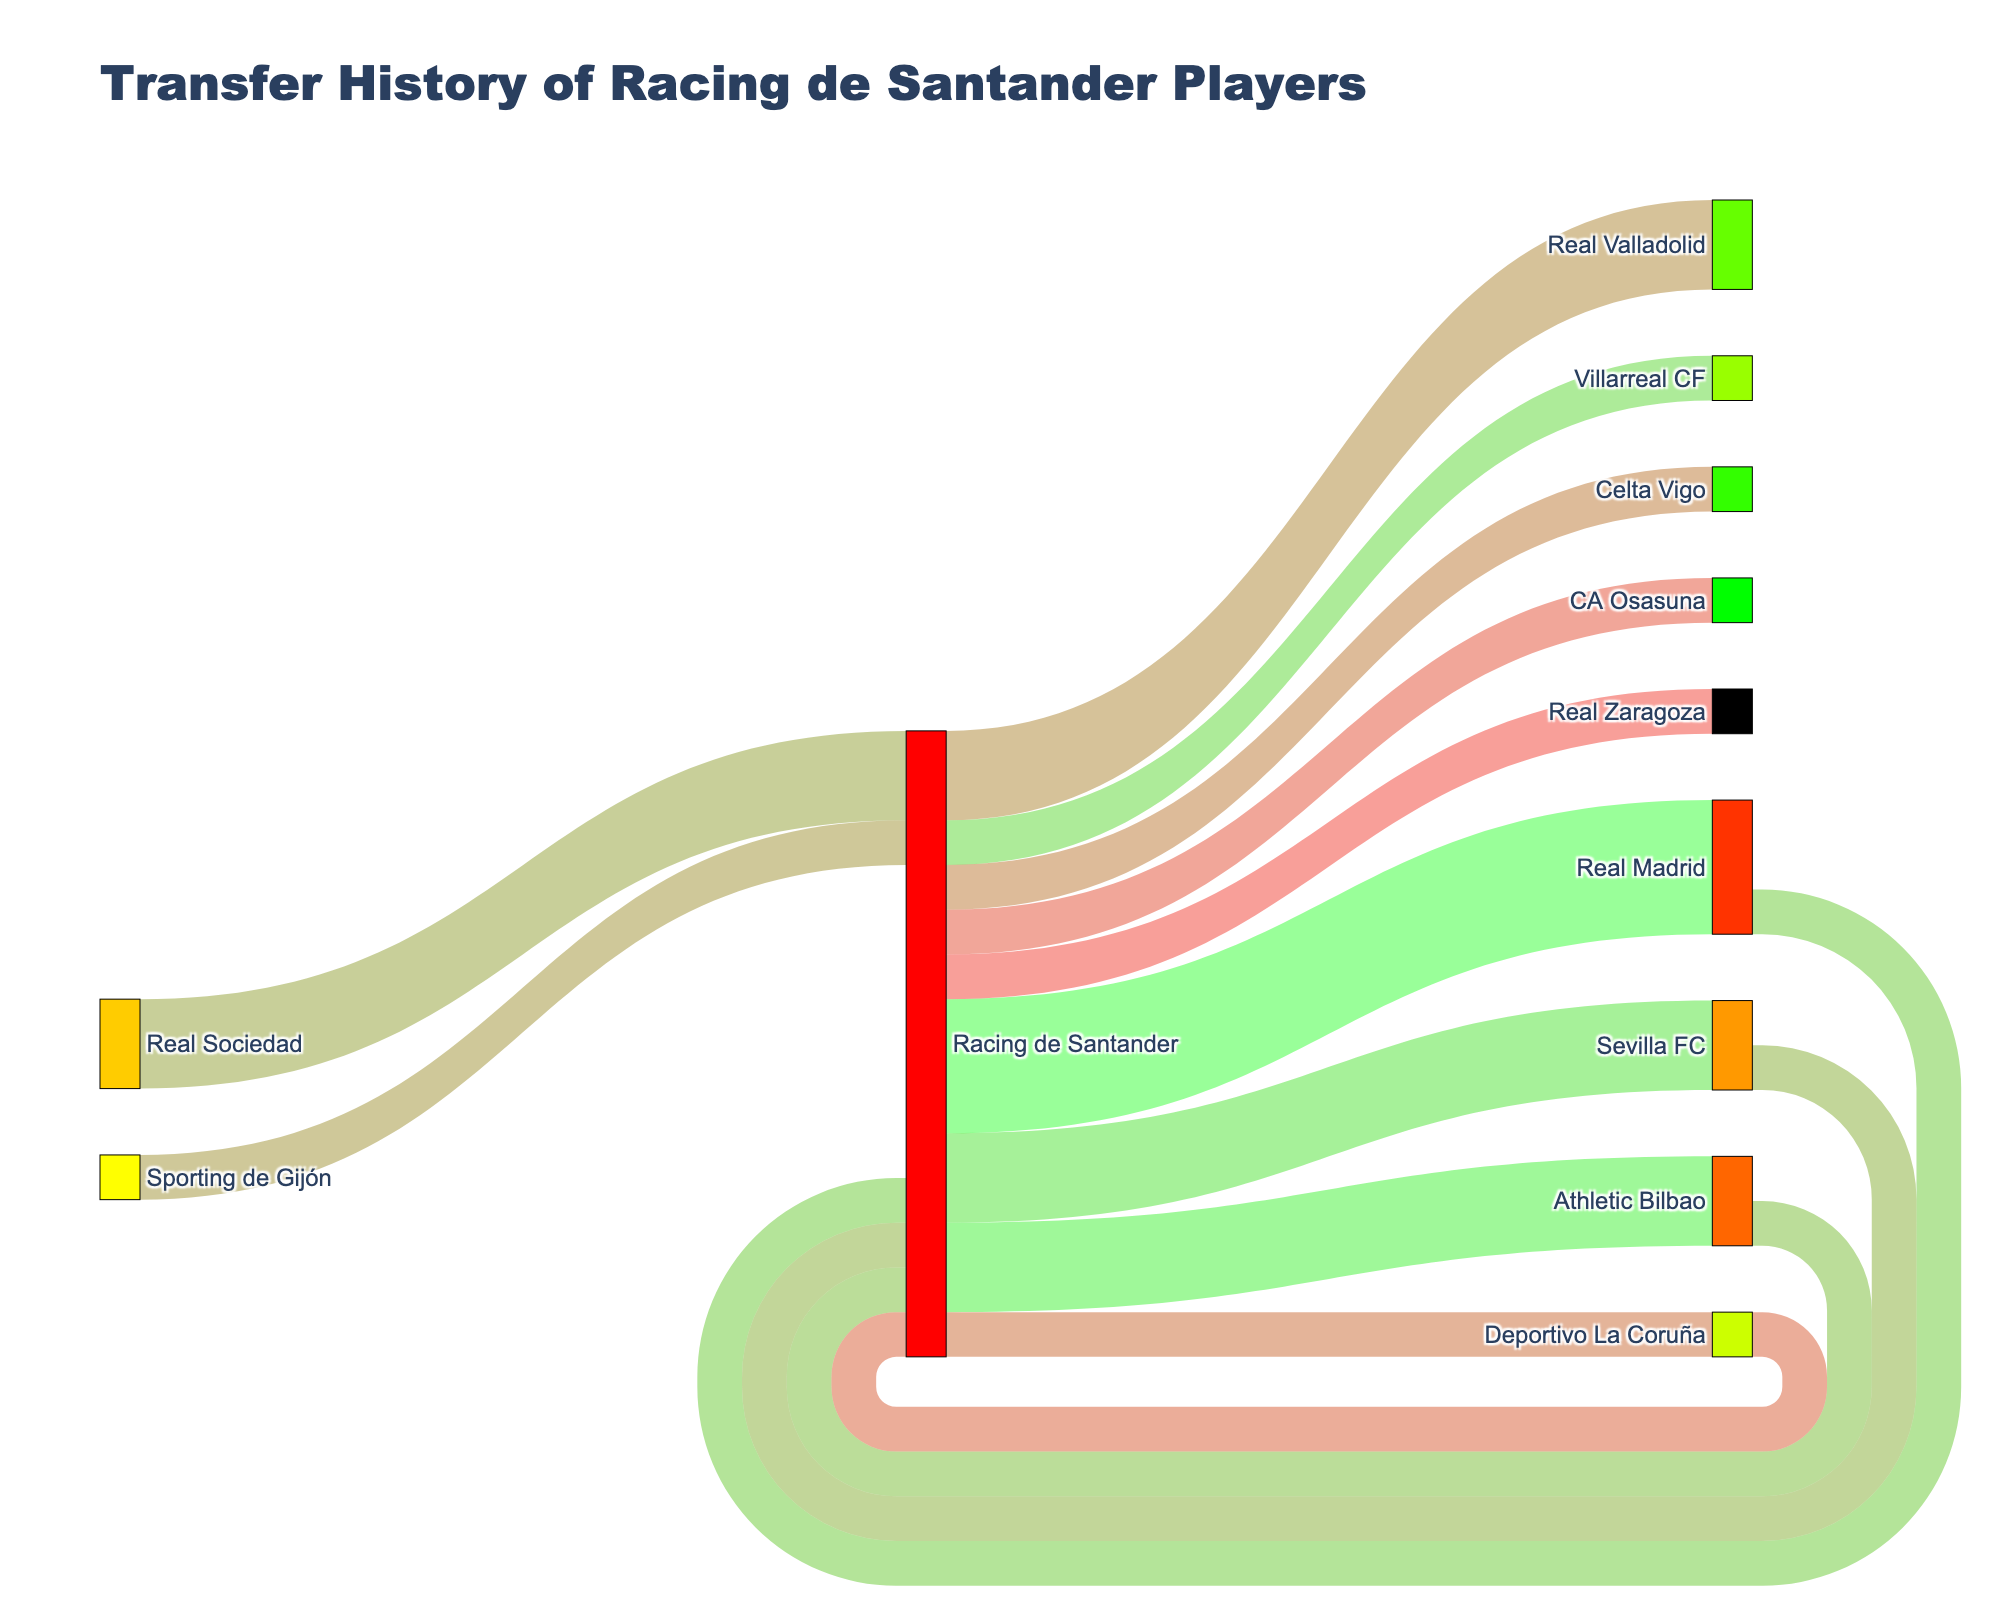How many clubs received players from Racing de Santander? Look at the number of unique target nodes connected to Racing de Santander. Racing de Santander has connections to Real Madrid, Athletic Bilbao, Sevilla FC, Villarreal CF, Real Valladolid, Celta Vigo, Deportivo La Coruña, CA Osasuna, and Real Zaragoza.
Answer: 9 Which club received the most players from Racing de Santander? Observe the target node with the highest value associated with Racing de Santander. Real Madrid received 3 players, which is higher than any other target node.
Answer: Real Madrid Which clubs have players transferred to Racing de Santander the most? Identify the number of unique source nodes connected to Racing de Santander excluding itself. Real Madrid, Athletic Bilbao, Sevilla FC, Real Sociedad, Sporting de Gijón, and Deportivo La Coruña each sent players to Racing de Santander. Real Sociedad sent players twice, which is the highest.
Answer: Real Sociedad How many players moved between Racing de Santander and Real Madrid in total? Sum up the values of transfers from Racing de Santander to Real Madrid and vice versa. Three players moved from Racing de Santander to Real Madrid and one moved back, giving a total of 4.
Answer: 4 Which club has the lowest number of incoming transfers from Racing de Santander and how many? Identify the target nodes with an incoming value of 1 from Racing de Santander. Villarreal CF, Celta Vigo, Deportivo La Coruña, CA Osasuna, and Real Zaragoza each have 1 incoming transfer.
Answer: Villarreal CF, Celta Vigo, Deportivo La Coruña, CA Osasuna, Real Zaragoza (each 1) How many total outgoing transfers did Racing de Santander have? Sum all the values from Racing de Santander to other clubs. Values are 3 + 2 + 2 + 1 + 2 + 1 + 1 + 1 + 1, summing to 14.
Answer: 14 Which club has the fewest outgoing transfers to Racing de Santander and how many? Identify the source nodes with an outgoing value of 1 to Racing de Santander. Real Madrid, Athletic Bilbao, Sevilla FC, Sporting de Gijón, and Deportivo La Coruña each have 1 outgoing transfer.
Answer: Real Madrid, Athletic Bilbao, Sevilla FC, Sporting de Gijón, Deportivo La Coruña (each 1) Compare the number of transfers from Racing de Santander to Sevilla FC with those from Sevilla FC to Racing de Santander. Which is higher and by how much? Racing de Santander to Sevilla FC has 2 transfers, whereas Sevilla FC to Racing de Santander has 1 transfer, so Racing de Santander to Sevilla FC is higher by 1.
Answer: Racing de Santander to Sevilla FC by 1 